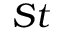Convert formula to latex. <formula><loc_0><loc_0><loc_500><loc_500>S t</formula> 